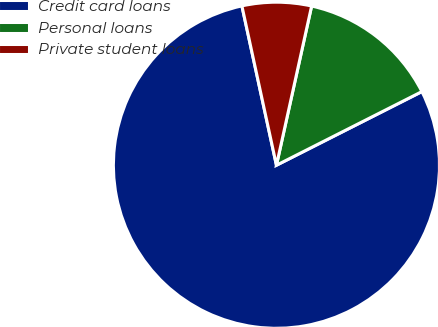Convert chart to OTSL. <chart><loc_0><loc_0><loc_500><loc_500><pie_chart><fcel>Credit card loans<fcel>Personal loans<fcel>Private student loans<nl><fcel>79.07%<fcel>14.08%<fcel>6.86%<nl></chart> 